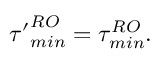<formula> <loc_0><loc_0><loc_500><loc_500>{ \tau ^ { \prime } } _ { \min } ^ { R O } = \tau _ { \min } ^ { R O } .</formula> 